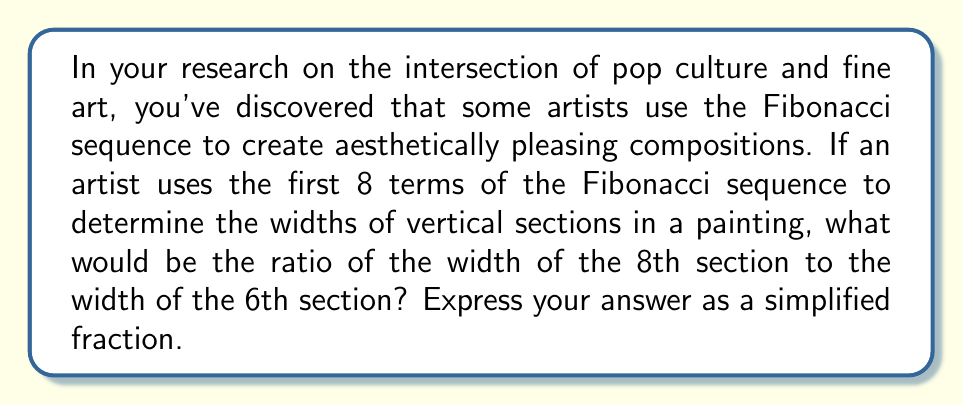Provide a solution to this math problem. Let's approach this step-by-step:

1) First, recall the Fibonacci sequence. Each number is the sum of the two preceding ones:

   $F_n = F_{n-1} + F_{n-2}$

2) The first 8 terms of the Fibonacci sequence are:
   
   1, 1, 2, 3, 5, 8, 13, 21

3) In this problem, we're interested in the ratio of the 8th term to the 6th term:

   $\frac{F_8}{F_6} = \frac{21}{8}$

4) This fraction is already in its simplest form, as 21 and 8 have no common factors other than 1.

Therefore, the ratio of the width of the 8th section to the width of the 6th section would be 21:8.
Answer: $\frac{21}{8}$ 